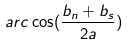<formula> <loc_0><loc_0><loc_500><loc_500>a r c \cos ( \frac { b _ { n } + b _ { s } } { 2 a } )</formula> 